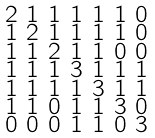<formula> <loc_0><loc_0><loc_500><loc_500>\begin{smallmatrix} 2 & 1 & 1 & 1 & 1 & 1 & 0 \\ 1 & 2 & 1 & 1 & 1 & 1 & 0 \\ 1 & 1 & 2 & 1 & 1 & 0 & 0 \\ 1 & 1 & 1 & 3 & 1 & 1 & 1 \\ 1 & 1 & 1 & 1 & 3 & 1 & 1 \\ 1 & 1 & 0 & 1 & 1 & 3 & 0 \\ 0 & 0 & 0 & 1 & 1 & 0 & 3 \end{smallmatrix}</formula> 